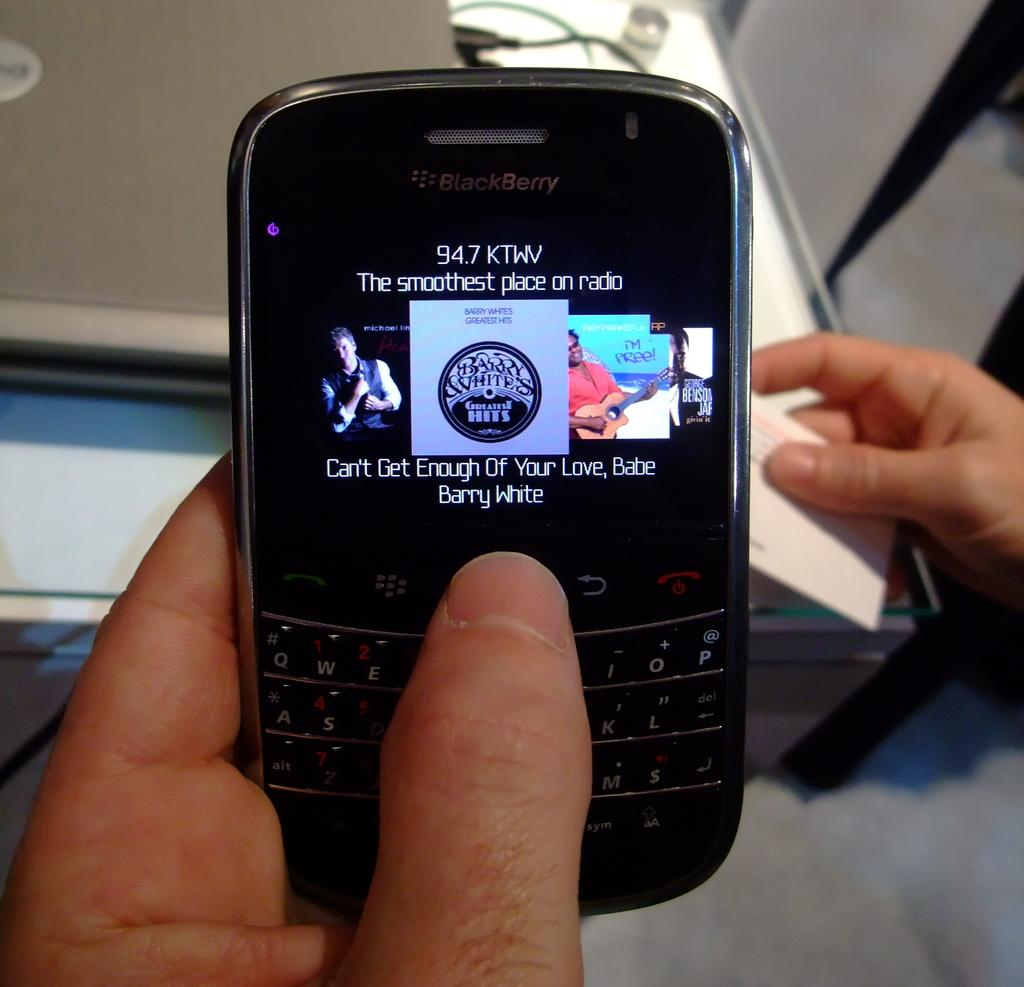<image>
Give a short and clear explanation of the subsequent image. A person is holding a Blackberry phone that is tuned to 94.7 KTWV radio station. 